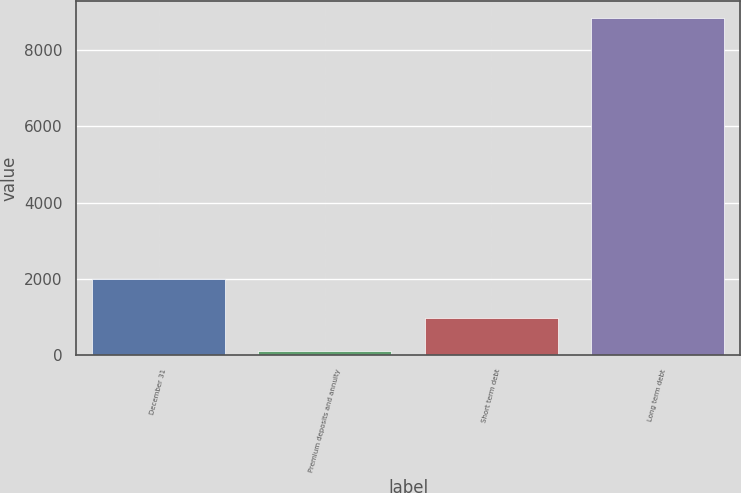<chart> <loc_0><loc_0><loc_500><loc_500><bar_chart><fcel>December 31<fcel>Premium deposits and annuity<fcel>Short term debt<fcel>Long term debt<nl><fcel>2010<fcel>104<fcel>976.6<fcel>8830<nl></chart> 